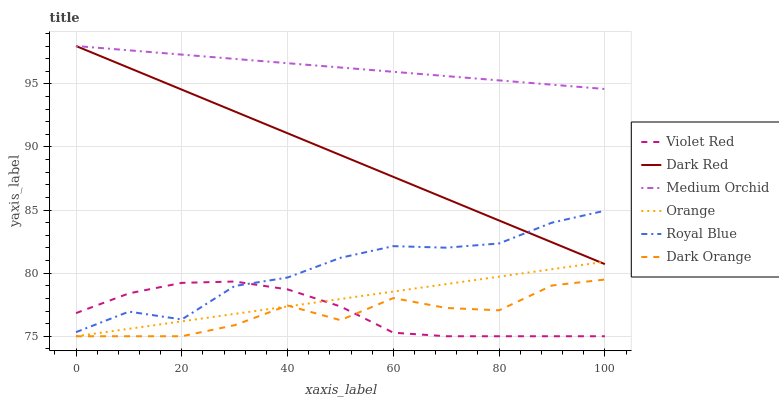Does Dark Orange have the minimum area under the curve?
Answer yes or no. Yes. Does Medium Orchid have the maximum area under the curve?
Answer yes or no. Yes. Does Violet Red have the minimum area under the curve?
Answer yes or no. No. Does Violet Red have the maximum area under the curve?
Answer yes or no. No. Is Dark Red the smoothest?
Answer yes or no. Yes. Is Dark Orange the roughest?
Answer yes or no. Yes. Is Violet Red the smoothest?
Answer yes or no. No. Is Violet Red the roughest?
Answer yes or no. No. Does Dark Red have the lowest value?
Answer yes or no. No. Does Medium Orchid have the highest value?
Answer yes or no. Yes. Does Violet Red have the highest value?
Answer yes or no. No. Is Royal Blue less than Medium Orchid?
Answer yes or no. Yes. Is Medium Orchid greater than Orange?
Answer yes or no. Yes. Does Dark Orange intersect Orange?
Answer yes or no. Yes. Is Dark Orange less than Orange?
Answer yes or no. No. Is Dark Orange greater than Orange?
Answer yes or no. No. Does Royal Blue intersect Medium Orchid?
Answer yes or no. No. 